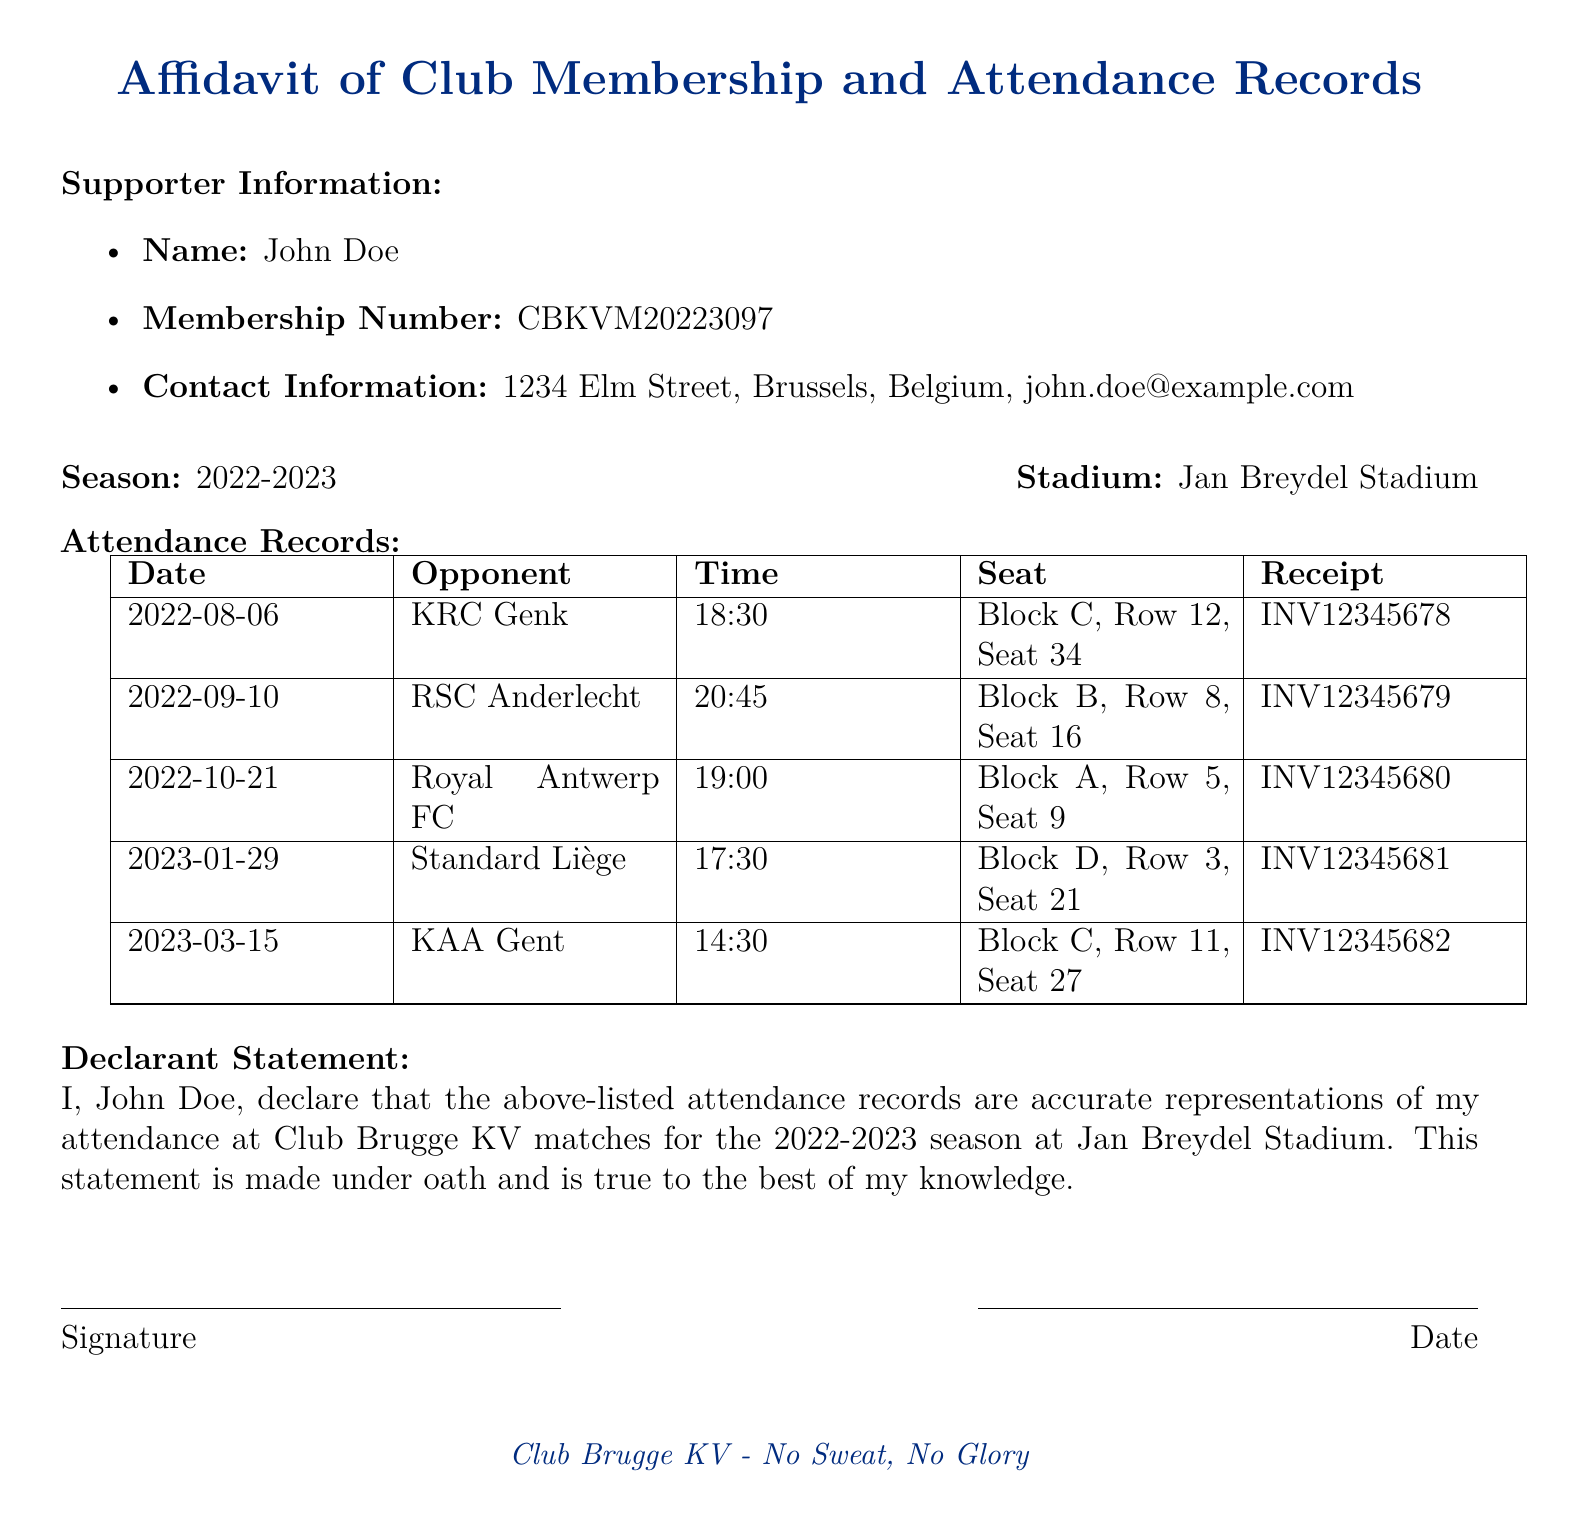What is the name of the supporter? The supporter is identified as John Doe in the document.
Answer: John Doe What is the membership number? The membership number listed is a unique identifier for the supporter.
Answer: CBKVM20223097 What is the season mentioned in the document? The season indicated in the document reflects the matches attended by the supporter.
Answer: 2022-2023 How many matches did John Doe attend? The attendance records list a total of five matches in the document.
Answer: 5 What is the date of the match against RSC Anderlecht? The specific date for this match is stated clearly in the attendance records.
Answer: 2022-09-10 What was the seat number for the match against KRC Genk? The document specifies the exact seat used by the supporter for this match.
Answer: Block C, Row 12, Seat 34 What time did the match against KAA Gent start? The time of the match is recorded in the attendance records section.
Answer: 14:30 What is the receipt number for the match on 2023-01-29? Each attendance is recorded with its respective receipt for verification.
Answer: INV12345681 How does the declarant sign the document? The signature line is for the declarant to affirm the accuracy of their statements.
Answer: Signature 